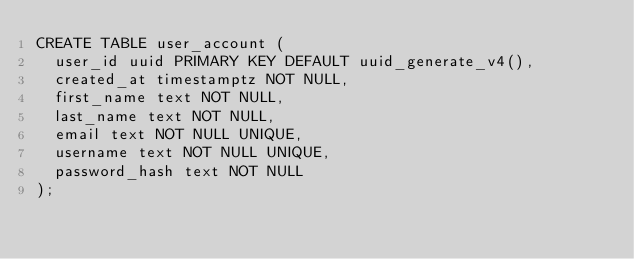Convert code to text. <code><loc_0><loc_0><loc_500><loc_500><_SQL_>CREATE TABLE user_account (
  user_id uuid PRIMARY KEY DEFAULT uuid_generate_v4(),
  created_at timestamptz NOT NULL,
  first_name text NOT NULL,
  last_name text NOT NULL,
  email text NOT NULL UNIQUE,
  username text NOT NULL UNIQUE,
  password_hash text NOT NULL
);
</code> 